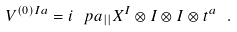Convert formula to latex. <formula><loc_0><loc_0><loc_500><loc_500>V ^ { ( 0 ) I a } = i \ p a _ { | | } X ^ { I } \otimes I \otimes I \otimes t ^ { a } \ .</formula> 